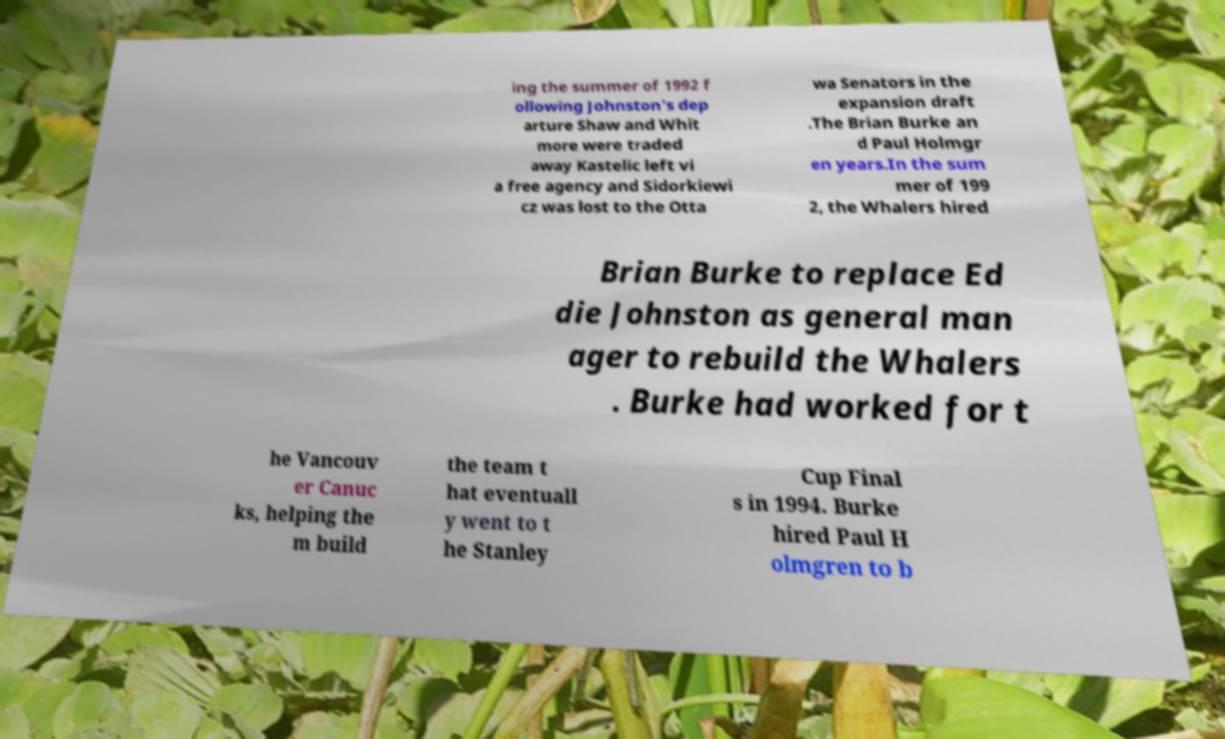There's text embedded in this image that I need extracted. Can you transcribe it verbatim? ing the summer of 1992 f ollowing Johnston's dep arture Shaw and Whit more were traded away Kastelic left vi a free agency and Sidorkiewi cz was lost to the Otta wa Senators in the expansion draft .The Brian Burke an d Paul Holmgr en years.In the sum mer of 199 2, the Whalers hired Brian Burke to replace Ed die Johnston as general man ager to rebuild the Whalers . Burke had worked for t he Vancouv er Canuc ks, helping the m build the team t hat eventuall y went to t he Stanley Cup Final s in 1994. Burke hired Paul H olmgren to b 